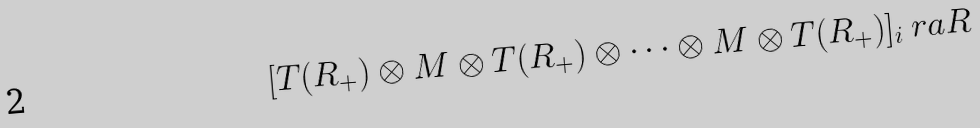Convert formula to latex. <formula><loc_0><loc_0><loc_500><loc_500>[ T ( R _ { + } ) \otimes M \otimes T ( R _ { + } ) \otimes \dots \otimes M \otimes T ( R _ { + } ) ] _ { i } \ r a R</formula> 